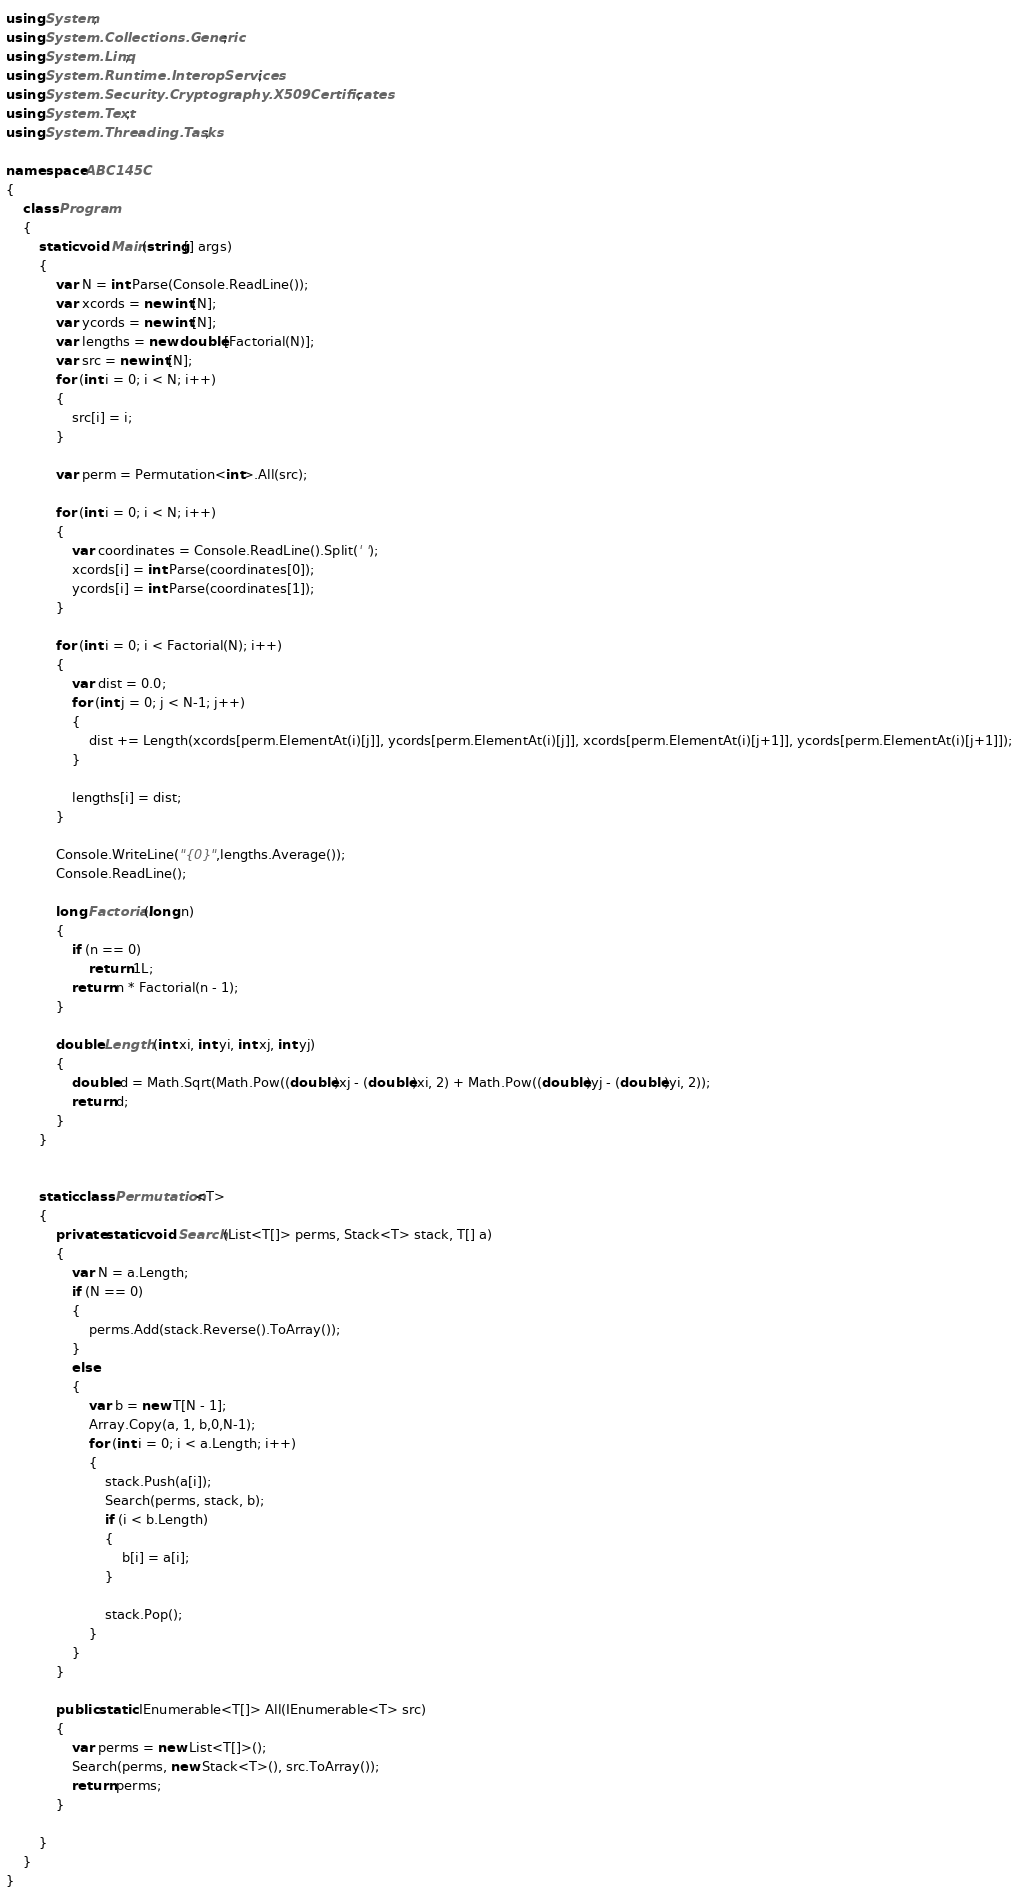Convert code to text. <code><loc_0><loc_0><loc_500><loc_500><_C#_>using System;
using System.Collections.Generic;
using System.Linq;
using System.Runtime.InteropServices;
using System.Security.Cryptography.X509Certificates;
using System.Text;
using System.Threading.Tasks;

namespace ABC145C
{
    class Program
    {
        static void Main(string[] args)
        {
            var N = int.Parse(Console.ReadLine());
            var xcords = new int[N];
            var ycords = new int[N];
            var lengths = new double[Factorial(N)];
            var src = new int[N];
            for (int i = 0; i < N; i++)
            {
                src[i] = i;
            }

            var perm = Permutation<int>.All(src);

            for (int i = 0; i < N; i++)
            {
                var coordinates = Console.ReadLine().Split(' ');
                xcords[i] = int.Parse(coordinates[0]);
                ycords[i] = int.Parse(coordinates[1]);
            }

            for (int i = 0; i < Factorial(N); i++)
            {
                var dist = 0.0;
                for (int j = 0; j < N-1; j++)
                {
                    dist += Length(xcords[perm.ElementAt(i)[j]], ycords[perm.ElementAt(i)[j]], xcords[perm.ElementAt(i)[j+1]], ycords[perm.ElementAt(i)[j+1]]);
                }

                lengths[i] = dist;
            }

            Console.WriteLine("{0}",lengths.Average());
            Console.ReadLine();
            
            long Factorial(long n)
            {
                if (n == 0)
                    return 1L;
                return n * Factorial(n - 1);
            }

            double Length (int xi, int yi, int xj, int yj)
            {
                double d = Math.Sqrt(Math.Pow((double)xj - (double)xi, 2) + Math.Pow((double)yj - (double)yi, 2));
                return d;
            }
        }


        static class Permutation<T>
        {
            private static void Search(List<T[]> perms, Stack<T> stack, T[] a)
            {
                var N = a.Length;
                if (N == 0)
                {
                    perms.Add(stack.Reverse().ToArray());
                }
                else
                {
                    var b = new T[N - 1];
                    Array.Copy(a, 1, b,0,N-1);
                    for (int i = 0; i < a.Length; i++)
                    {
                        stack.Push(a[i]);
                        Search(perms, stack, b);
                        if (i < b.Length)
                        {
                            b[i] = a[i];
                        }

                        stack.Pop();
                    }
                }
            }

            public static IEnumerable<T[]> All(IEnumerable<T> src)
            {
                var perms = new List<T[]>();
                Search(perms, new Stack<T>(), src.ToArray());
                return perms;
            }

        }
    }
}
</code> 